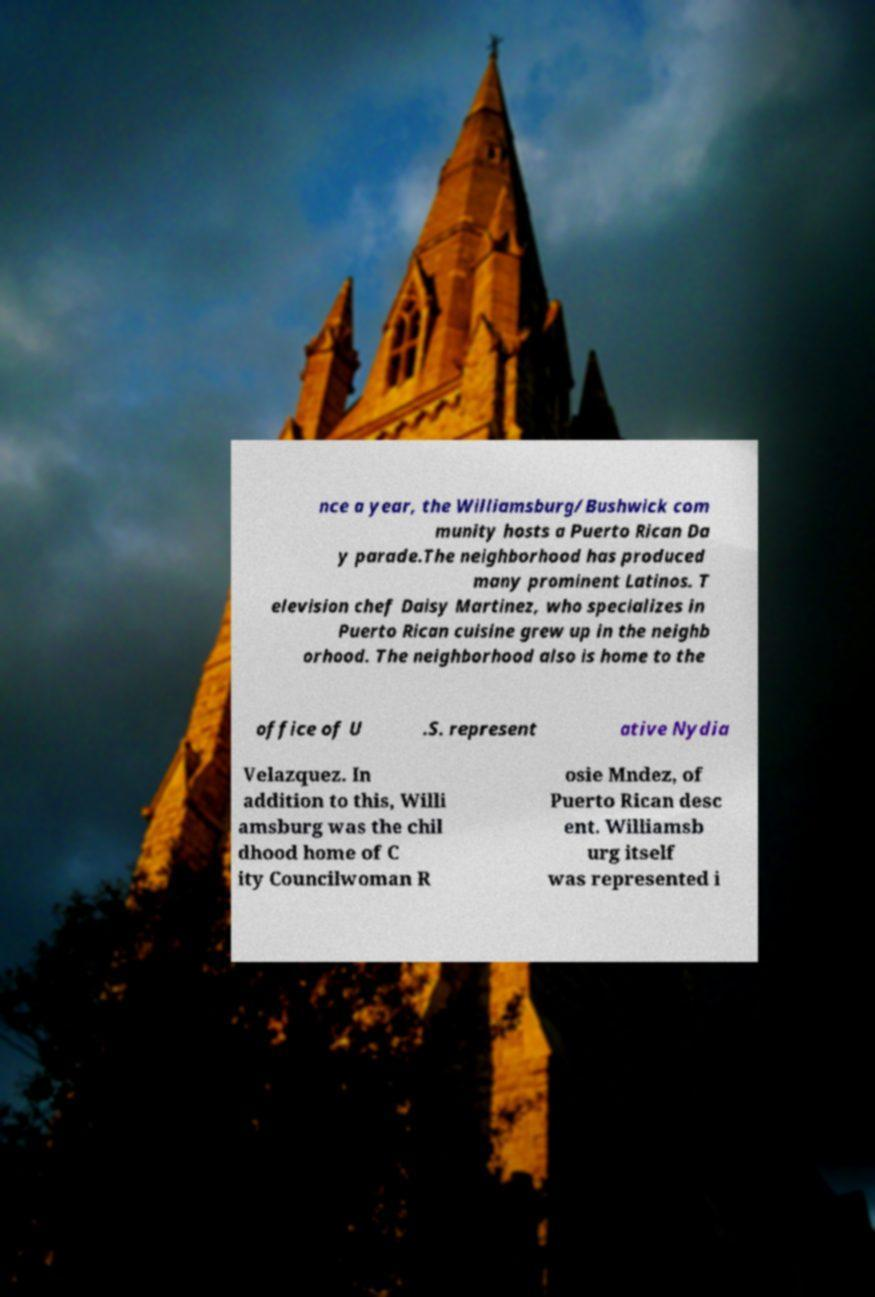Please read and relay the text visible in this image. What does it say? nce a year, the Williamsburg/Bushwick com munity hosts a Puerto Rican Da y parade.The neighborhood has produced many prominent Latinos. T elevision chef Daisy Martinez, who specializes in Puerto Rican cuisine grew up in the neighb orhood. The neighborhood also is home to the office of U .S. represent ative Nydia Velazquez. In addition to this, Willi amsburg was the chil dhood home of C ity Councilwoman R osie Mndez, of Puerto Rican desc ent. Williamsb urg itself was represented i 